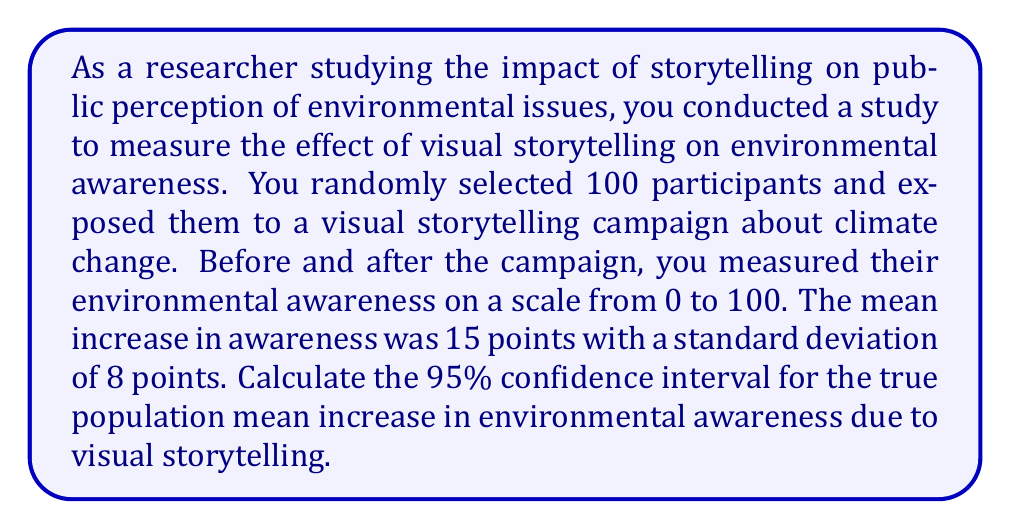Teach me how to tackle this problem. To calculate the confidence interval, we'll follow these steps:

1) We're dealing with a large sample (n > 30), so we can use the normal distribution.

2) The formula for the confidence interval is:

   $$ \bar{x} \pm z_{\alpha/2} \cdot \frac{s}{\sqrt{n}} $$

   Where:
   $\bar{x}$ is the sample mean
   $z_{\alpha/2}$ is the z-score for the desired confidence level
   $s$ is the sample standard deviation
   $n$ is the sample size

3) We know:
   $\bar{x} = 15$
   $s = 8$
   $n = 100$
   For a 95% confidence interval, $z_{\alpha/2} = 1.96$

4) Let's substitute these values into the formula:

   $$ 15 \pm 1.96 \cdot \frac{8}{\sqrt{100}} $$

5) Simplify:
   $$ 15 \pm 1.96 \cdot \frac{8}{10} = 15 \pm 1.96 \cdot 0.8 = 15 \pm 1.568 $$

6) Calculate the lower and upper bounds:
   Lower bound: $15 - 1.568 = 13.432$
   Upper bound: $15 + 1.568 = 16.568$

7) Round to two decimal places:
   $$ (13.43, 16.57) $$
Answer: (13.43, 16.57) 